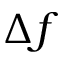<formula> <loc_0><loc_0><loc_500><loc_500>\Delta f</formula> 